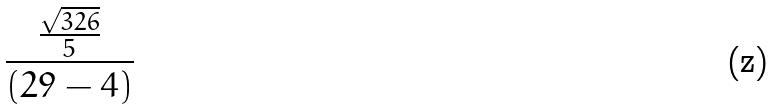Convert formula to latex. <formula><loc_0><loc_0><loc_500><loc_500>\frac { \frac { \sqrt { 3 2 6 } } { 5 } } { ( 2 9 - 4 ) }</formula> 